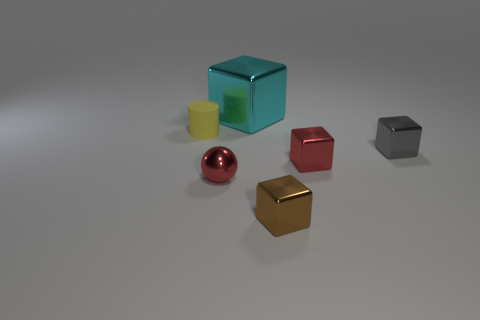The metal object that is the same color as the sphere is what shape?
Give a very brief answer. Cube. Are there any tiny objects of the same color as the tiny sphere?
Ensure brevity in your answer.  Yes. What size is the cube that is the same color as the small ball?
Make the answer very short. Small. Is there anything else that has the same material as the yellow cylinder?
Provide a short and direct response. No. Are there fewer cyan metal blocks in front of the small gray thing than tiny red metallic spheres?
Your response must be concise. Yes. There is a tiny shiny object that is behind the small red metallic thing that is right of the red metal ball; what is its color?
Give a very brief answer. Gray. What is the size of the shiny object that is behind the cylinder behind the red thing that is on the left side of the big cyan thing?
Provide a short and direct response. Large. Are there fewer tiny cylinders in front of the matte object than small yellow cylinders that are in front of the small red metal cube?
Provide a succinct answer. No. How many cylinders have the same material as the cyan block?
Provide a succinct answer. 0. Are there any tiny metallic objects left of the tiny red object right of the object that is behind the tiny yellow cylinder?
Ensure brevity in your answer.  Yes. 